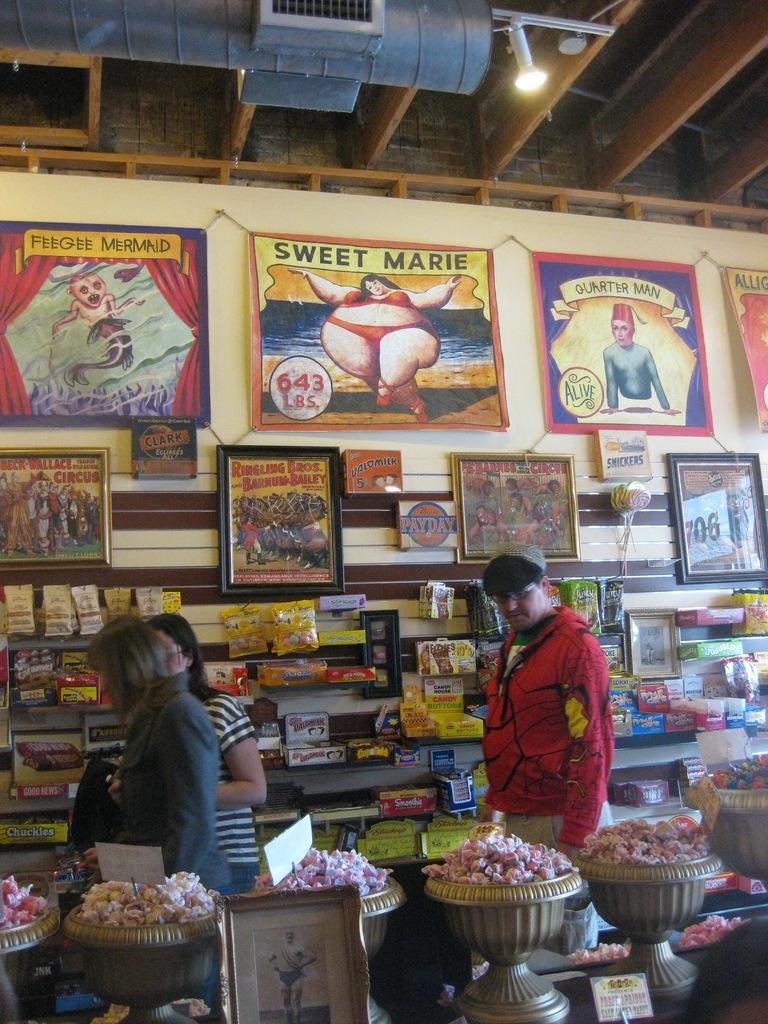What types of items can be seen in the image? There are boxes, packets, objects on shelves, photo frames, and posters in the image. Where are these items located? The items are located on shelves, attached to the wall, and in photo frames in the image. What can be seen on the wall in the image? There are posters and objects attached to the wall in the image. What type of decorative items are present in the image? Photo frames are present in the image as decorative items. Can you read the writing on the wren in the image? There is no wren or writing present in the image. 